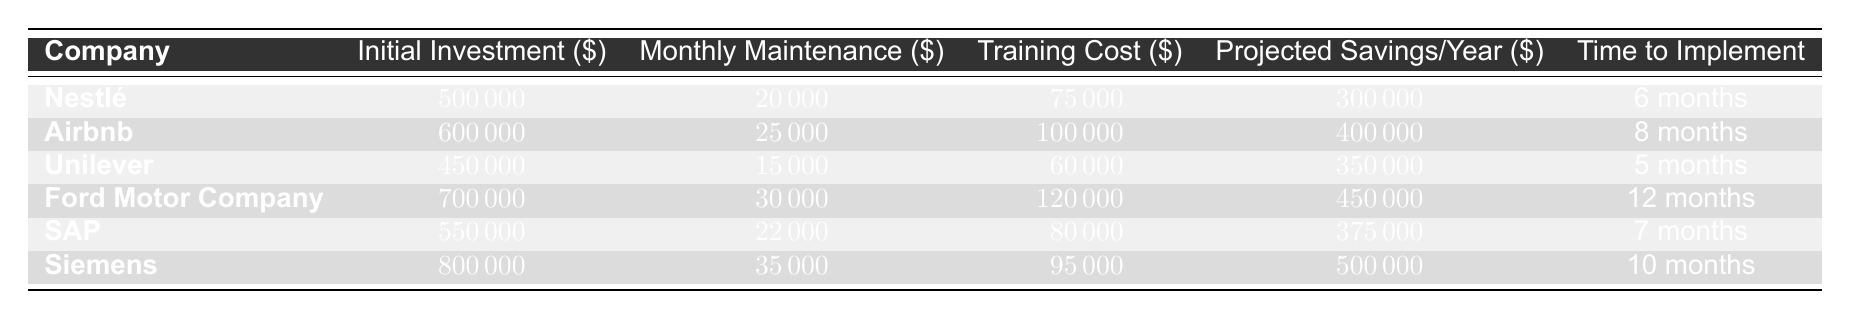What is the initial investment for Nestlé? The table lists the initial investment for each company. For Nestlé, it specifies an initial investment of $500,000.
Answer: $500,000 Which company has the highest projected savings per year? By comparing the projected savings per year for all companies, Ford Motor Company has the highest amount at $450,000.
Answer: Ford Motor Company What is the total monthly maintenance cost for all companies combined? The monthly maintenance costs are $20,000 for Nestlé, $25,000 for Airbnb, $15,000 for Unilever, $30,000 for Ford Motor Company, $22,000 for SAP, and $35,000 for Siemens. Adding these values gives a total of $20,000 + $25,000 + $15,000 + $30,000 + $22,000 + $35,000 = $147,000.
Answer: $147,000 Which company has the shortest time to implement machine translation? The time to implement is listed next to each company. Unilever has the shortest time at 5 months.
Answer: Unilever What is the average training cost among the companies? The training costs are $75,000 for Nestlé, $100,000 for Airbnb, $60,000 for Unilever, $120,000 for Ford Motor Company, $80,000 for SAP, and $95,000 for Siemens. Summing these gives $75,000 + $100,000 + $60,000 + $120,000 + $80,000 + $95,000 = $530,000. Dividing by 6 (the number of companies) results in an average training cost of $530,000 / 6 = $88,333.33.
Answer: $88,333.33 Is the monthly maintenance cost for Siemens higher than that of Airbnb? Comparing the monthly maintenance costs, Siemens has $35,000 while Airbnb has $25,000. Since $35,000 is greater than $25,000, the statement is true.
Answer: Yes How much more is the initial investment for Ford Motor Company compared to Unilever? The initial investment for Ford Motor Company is $700,000 and for Unilever it is $450,000. Subtracting these amounts gives $700,000 - $450,000 = $250,000.
Answer: $250,000 Which company has a projected savings per year that is less than $350,000? Reviewing the projected savings per year, both Nestlé ($300,000) and SAP ($375,000) have savings of less than $350,000. Therefore, only Nestlé qualifies.
Answer: Nestlé What is the total initial investment across all companies? The initial investments are $500,000 for Nestlé, $600,000 for Airbnb, $450,000 for Unilever, $700,000 for Ford Motor Company, $550,000 for SAP, and $800,000 for Siemens. Adding these amounts gives a total of $500,000 + $600,000 + $450,000 + $700,000 + $550,000 + $800,000 = $3,600,000.
Answer: $3,600,000 Does the training cost for SAP exceed the average training cost of the companies? The training cost for SAP is $80,000. The average training cost calculated previously is $88,333.33. Since $80,000 is less than $88,333.33, the statement is false.
Answer: No What company requires the longest time to implement machine translation? The table shows the time to implement for each company. Ford Motor Company requires the longest time at 12 months.
Answer: Ford Motor Company 